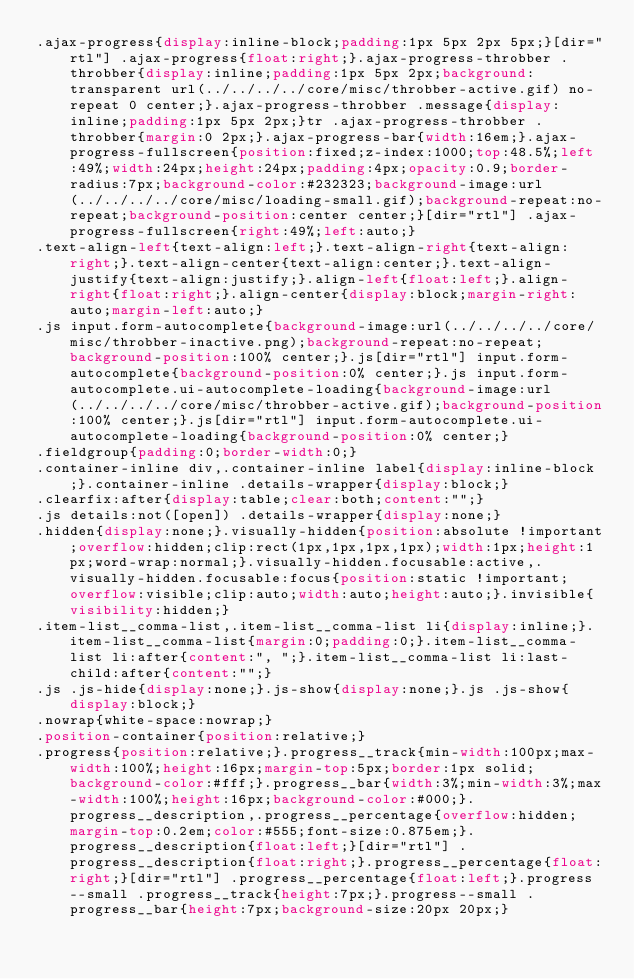Convert code to text. <code><loc_0><loc_0><loc_500><loc_500><_CSS_>.ajax-progress{display:inline-block;padding:1px 5px 2px 5px;}[dir="rtl"] .ajax-progress{float:right;}.ajax-progress-throbber .throbber{display:inline;padding:1px 5px 2px;background:transparent url(../../../../core/misc/throbber-active.gif) no-repeat 0 center;}.ajax-progress-throbber .message{display:inline;padding:1px 5px 2px;}tr .ajax-progress-throbber .throbber{margin:0 2px;}.ajax-progress-bar{width:16em;}.ajax-progress-fullscreen{position:fixed;z-index:1000;top:48.5%;left:49%;width:24px;height:24px;padding:4px;opacity:0.9;border-radius:7px;background-color:#232323;background-image:url(../../../../core/misc/loading-small.gif);background-repeat:no-repeat;background-position:center center;}[dir="rtl"] .ajax-progress-fullscreen{right:49%;left:auto;}
.text-align-left{text-align:left;}.text-align-right{text-align:right;}.text-align-center{text-align:center;}.text-align-justify{text-align:justify;}.align-left{float:left;}.align-right{float:right;}.align-center{display:block;margin-right:auto;margin-left:auto;}
.js input.form-autocomplete{background-image:url(../../../../core/misc/throbber-inactive.png);background-repeat:no-repeat;background-position:100% center;}.js[dir="rtl"] input.form-autocomplete{background-position:0% center;}.js input.form-autocomplete.ui-autocomplete-loading{background-image:url(../../../../core/misc/throbber-active.gif);background-position:100% center;}.js[dir="rtl"] input.form-autocomplete.ui-autocomplete-loading{background-position:0% center;}
.fieldgroup{padding:0;border-width:0;}
.container-inline div,.container-inline label{display:inline-block;}.container-inline .details-wrapper{display:block;}
.clearfix:after{display:table;clear:both;content:"";}
.js details:not([open]) .details-wrapper{display:none;}
.hidden{display:none;}.visually-hidden{position:absolute !important;overflow:hidden;clip:rect(1px,1px,1px,1px);width:1px;height:1px;word-wrap:normal;}.visually-hidden.focusable:active,.visually-hidden.focusable:focus{position:static !important;overflow:visible;clip:auto;width:auto;height:auto;}.invisible{visibility:hidden;}
.item-list__comma-list,.item-list__comma-list li{display:inline;}.item-list__comma-list{margin:0;padding:0;}.item-list__comma-list li:after{content:", ";}.item-list__comma-list li:last-child:after{content:"";}
.js .js-hide{display:none;}.js-show{display:none;}.js .js-show{display:block;}
.nowrap{white-space:nowrap;}
.position-container{position:relative;}
.progress{position:relative;}.progress__track{min-width:100px;max-width:100%;height:16px;margin-top:5px;border:1px solid;background-color:#fff;}.progress__bar{width:3%;min-width:3%;max-width:100%;height:16px;background-color:#000;}.progress__description,.progress__percentage{overflow:hidden;margin-top:0.2em;color:#555;font-size:0.875em;}.progress__description{float:left;}[dir="rtl"] .progress__description{float:right;}.progress__percentage{float:right;}[dir="rtl"] .progress__percentage{float:left;}.progress--small .progress__track{height:7px;}.progress--small .progress__bar{height:7px;background-size:20px 20px;}</code> 